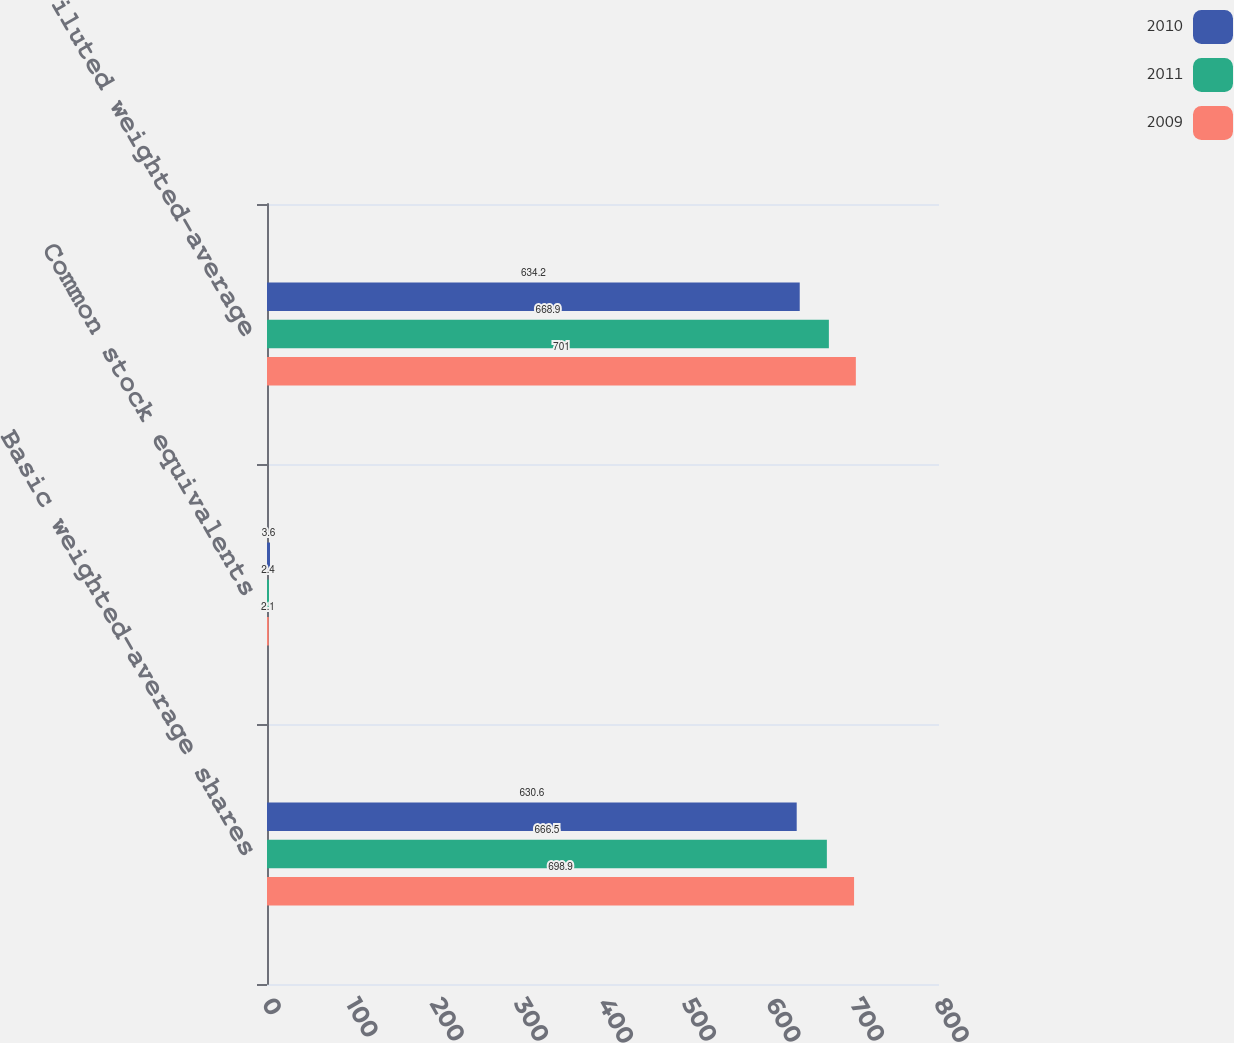<chart> <loc_0><loc_0><loc_500><loc_500><stacked_bar_chart><ecel><fcel>Basic weighted-average shares<fcel>Common stock equivalents<fcel>Diluted weighted-average<nl><fcel>2010<fcel>630.6<fcel>3.6<fcel>634.2<nl><fcel>2011<fcel>666.5<fcel>2.4<fcel>668.9<nl><fcel>2009<fcel>698.9<fcel>2.1<fcel>701<nl></chart> 